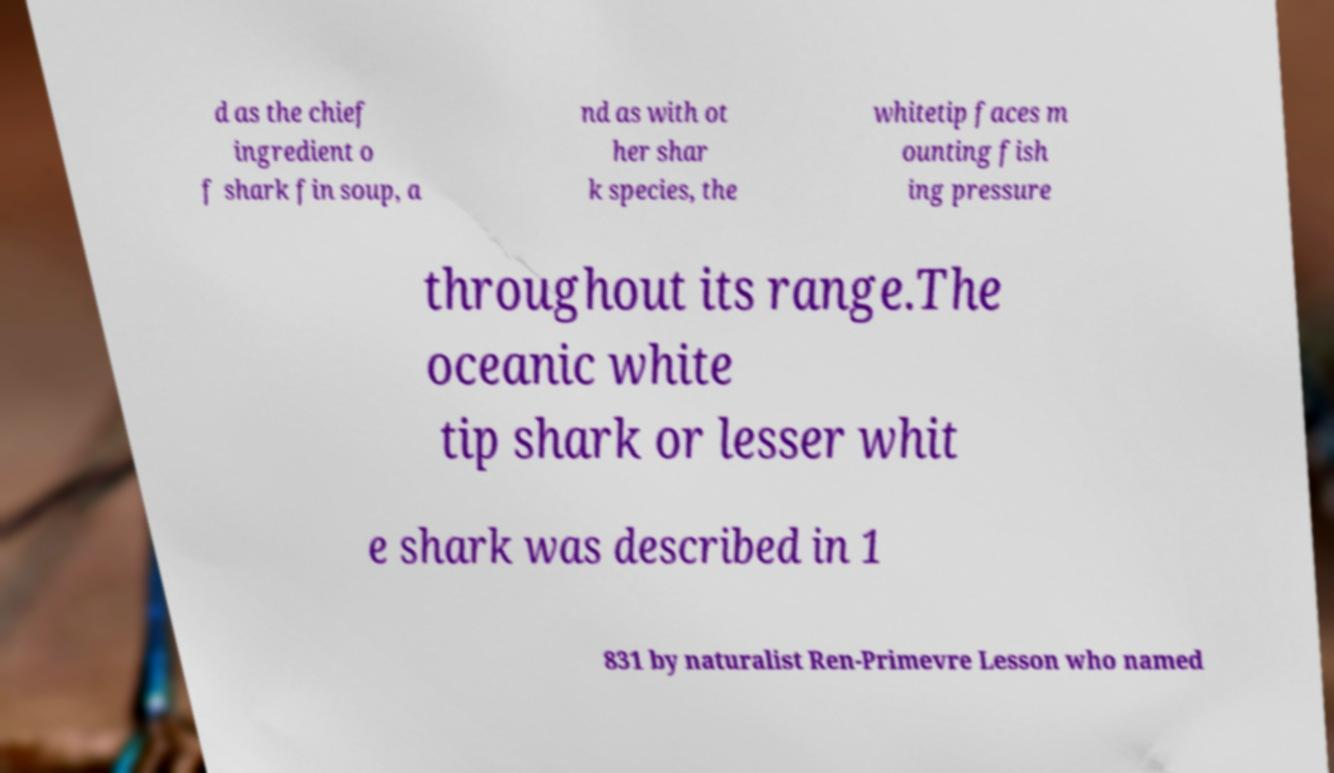Please read and relay the text visible in this image. What does it say? d as the chief ingredient o f shark fin soup, a nd as with ot her shar k species, the whitetip faces m ounting fish ing pressure throughout its range.The oceanic white tip shark or lesser whit e shark was described in 1 831 by naturalist Ren-Primevre Lesson who named 